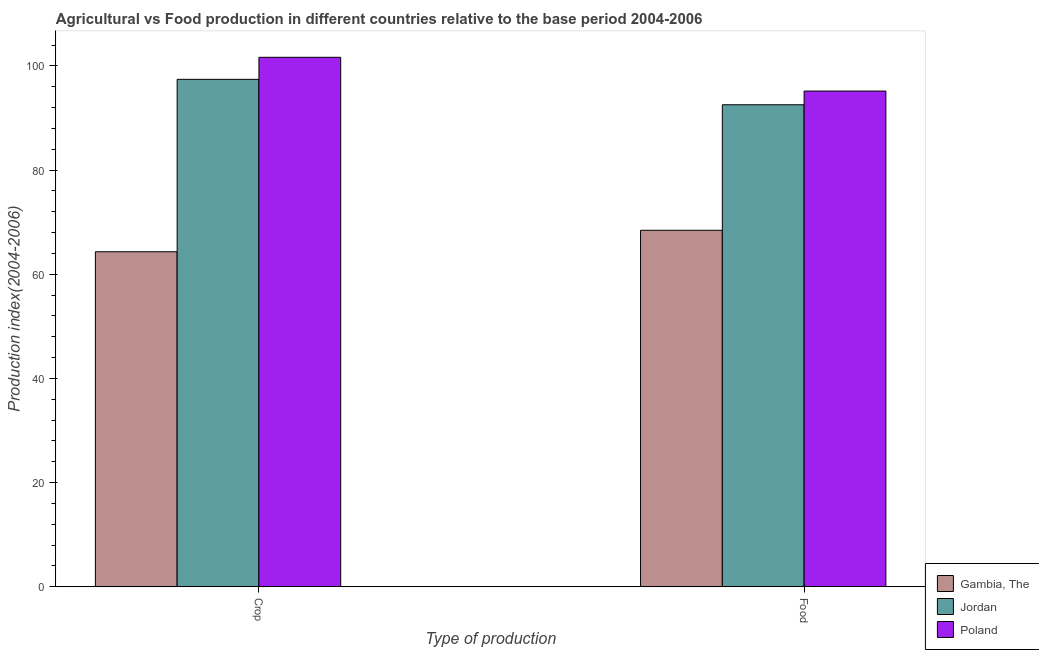How many different coloured bars are there?
Keep it short and to the point. 3. Are the number of bars on each tick of the X-axis equal?
Offer a terse response. Yes. How many bars are there on the 2nd tick from the left?
Ensure brevity in your answer.  3. How many bars are there on the 1st tick from the right?
Keep it short and to the point. 3. What is the label of the 1st group of bars from the left?
Ensure brevity in your answer.  Crop. What is the food production index in Jordan?
Ensure brevity in your answer.  92.53. Across all countries, what is the maximum crop production index?
Provide a short and direct response. 101.64. Across all countries, what is the minimum crop production index?
Keep it short and to the point. 64.31. In which country was the crop production index minimum?
Offer a very short reply. Gambia, The. What is the total crop production index in the graph?
Ensure brevity in your answer.  263.36. What is the difference between the crop production index in Jordan and that in Gambia, The?
Your answer should be compact. 33.1. What is the difference between the crop production index in Poland and the food production index in Jordan?
Make the answer very short. 9.11. What is the average food production index per country?
Offer a very short reply. 85.37. What is the difference between the food production index and crop production index in Gambia, The?
Your answer should be very brief. 4.12. In how many countries, is the food production index greater than 68 ?
Provide a succinct answer. 3. What is the ratio of the crop production index in Gambia, The to that in Poland?
Offer a very short reply. 0.63. In how many countries, is the crop production index greater than the average crop production index taken over all countries?
Make the answer very short. 2. What does the 1st bar from the left in Food represents?
Make the answer very short. Gambia, The. What does the 3rd bar from the right in Food represents?
Provide a short and direct response. Gambia, The. Are all the bars in the graph horizontal?
Offer a terse response. No. How many countries are there in the graph?
Give a very brief answer. 3. What is the difference between two consecutive major ticks on the Y-axis?
Give a very brief answer. 20. Are the values on the major ticks of Y-axis written in scientific E-notation?
Your answer should be compact. No. Does the graph contain any zero values?
Make the answer very short. No. Where does the legend appear in the graph?
Provide a succinct answer. Bottom right. How many legend labels are there?
Provide a succinct answer. 3. How are the legend labels stacked?
Make the answer very short. Vertical. What is the title of the graph?
Provide a short and direct response. Agricultural vs Food production in different countries relative to the base period 2004-2006. Does "South Africa" appear as one of the legend labels in the graph?
Give a very brief answer. No. What is the label or title of the X-axis?
Provide a short and direct response. Type of production. What is the label or title of the Y-axis?
Provide a short and direct response. Production index(2004-2006). What is the Production index(2004-2006) in Gambia, The in Crop?
Provide a short and direct response. 64.31. What is the Production index(2004-2006) in Jordan in Crop?
Give a very brief answer. 97.41. What is the Production index(2004-2006) in Poland in Crop?
Provide a short and direct response. 101.64. What is the Production index(2004-2006) in Gambia, The in Food?
Make the answer very short. 68.43. What is the Production index(2004-2006) in Jordan in Food?
Your answer should be very brief. 92.53. What is the Production index(2004-2006) of Poland in Food?
Ensure brevity in your answer.  95.16. Across all Type of production, what is the maximum Production index(2004-2006) in Gambia, The?
Offer a terse response. 68.43. Across all Type of production, what is the maximum Production index(2004-2006) of Jordan?
Provide a short and direct response. 97.41. Across all Type of production, what is the maximum Production index(2004-2006) in Poland?
Ensure brevity in your answer.  101.64. Across all Type of production, what is the minimum Production index(2004-2006) in Gambia, The?
Offer a terse response. 64.31. Across all Type of production, what is the minimum Production index(2004-2006) of Jordan?
Offer a terse response. 92.53. Across all Type of production, what is the minimum Production index(2004-2006) of Poland?
Make the answer very short. 95.16. What is the total Production index(2004-2006) of Gambia, The in the graph?
Your answer should be compact. 132.74. What is the total Production index(2004-2006) in Jordan in the graph?
Make the answer very short. 189.94. What is the total Production index(2004-2006) of Poland in the graph?
Your answer should be very brief. 196.8. What is the difference between the Production index(2004-2006) of Gambia, The in Crop and that in Food?
Offer a terse response. -4.12. What is the difference between the Production index(2004-2006) in Jordan in Crop and that in Food?
Keep it short and to the point. 4.88. What is the difference between the Production index(2004-2006) of Poland in Crop and that in Food?
Give a very brief answer. 6.48. What is the difference between the Production index(2004-2006) of Gambia, The in Crop and the Production index(2004-2006) of Jordan in Food?
Keep it short and to the point. -28.22. What is the difference between the Production index(2004-2006) in Gambia, The in Crop and the Production index(2004-2006) in Poland in Food?
Provide a succinct answer. -30.85. What is the difference between the Production index(2004-2006) in Jordan in Crop and the Production index(2004-2006) in Poland in Food?
Your answer should be compact. 2.25. What is the average Production index(2004-2006) in Gambia, The per Type of production?
Provide a succinct answer. 66.37. What is the average Production index(2004-2006) of Jordan per Type of production?
Provide a succinct answer. 94.97. What is the average Production index(2004-2006) of Poland per Type of production?
Give a very brief answer. 98.4. What is the difference between the Production index(2004-2006) in Gambia, The and Production index(2004-2006) in Jordan in Crop?
Offer a terse response. -33.1. What is the difference between the Production index(2004-2006) of Gambia, The and Production index(2004-2006) of Poland in Crop?
Give a very brief answer. -37.33. What is the difference between the Production index(2004-2006) of Jordan and Production index(2004-2006) of Poland in Crop?
Your answer should be very brief. -4.23. What is the difference between the Production index(2004-2006) in Gambia, The and Production index(2004-2006) in Jordan in Food?
Keep it short and to the point. -24.1. What is the difference between the Production index(2004-2006) in Gambia, The and Production index(2004-2006) in Poland in Food?
Ensure brevity in your answer.  -26.73. What is the difference between the Production index(2004-2006) of Jordan and Production index(2004-2006) of Poland in Food?
Keep it short and to the point. -2.63. What is the ratio of the Production index(2004-2006) in Gambia, The in Crop to that in Food?
Keep it short and to the point. 0.94. What is the ratio of the Production index(2004-2006) in Jordan in Crop to that in Food?
Ensure brevity in your answer.  1.05. What is the ratio of the Production index(2004-2006) in Poland in Crop to that in Food?
Make the answer very short. 1.07. What is the difference between the highest and the second highest Production index(2004-2006) of Gambia, The?
Offer a very short reply. 4.12. What is the difference between the highest and the second highest Production index(2004-2006) of Jordan?
Your answer should be very brief. 4.88. What is the difference between the highest and the second highest Production index(2004-2006) of Poland?
Your answer should be compact. 6.48. What is the difference between the highest and the lowest Production index(2004-2006) in Gambia, The?
Provide a short and direct response. 4.12. What is the difference between the highest and the lowest Production index(2004-2006) of Jordan?
Provide a short and direct response. 4.88. What is the difference between the highest and the lowest Production index(2004-2006) in Poland?
Give a very brief answer. 6.48. 